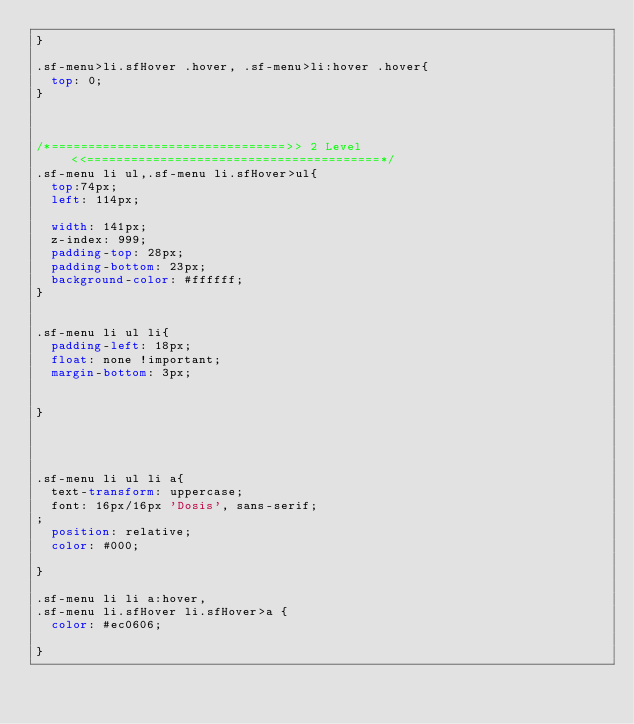<code> <loc_0><loc_0><loc_500><loc_500><_CSS_>}

.sf-menu>li.sfHover .hover, .sf-menu>li:hover .hover{
	top: 0;
}



/*================================>> 2 Level <<========================================*/
.sf-menu li ul,.sf-menu li.sfHover>ul{
	top:74px;
	left: 114px;

	width: 141px;
	z-index: 999; 
	padding-top: 28px;
	padding-bottom: 23px;
	background-color: #ffffff;
}


.sf-menu li ul li{
	padding-left: 18px;
	float: none !important; 
	margin-bottom: 3px;


}




.sf-menu li ul li a{
	text-transform: uppercase;
	font: 16px/16px 'Dosis', sans-serif;
;
	position: relative;
	color: #000;

}

.sf-menu li li a:hover, 
.sf-menu li.sfHover li.sfHover>a {  
	color: #ec0606;

}

</code> 